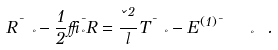Convert formula to latex. <formula><loc_0><loc_0><loc_500><loc_500>R _ { \ \nu } ^ { \mu } - { \frac { 1 } { 2 } } \delta _ { \nu } ^ { \mu } R = { \frac { \kappa ^ { 2 } } { l } } T _ { \ \nu } ^ { \mu } - E _ { \quad \ \nu } ^ { ( 1 ) \mu } \ .</formula> 